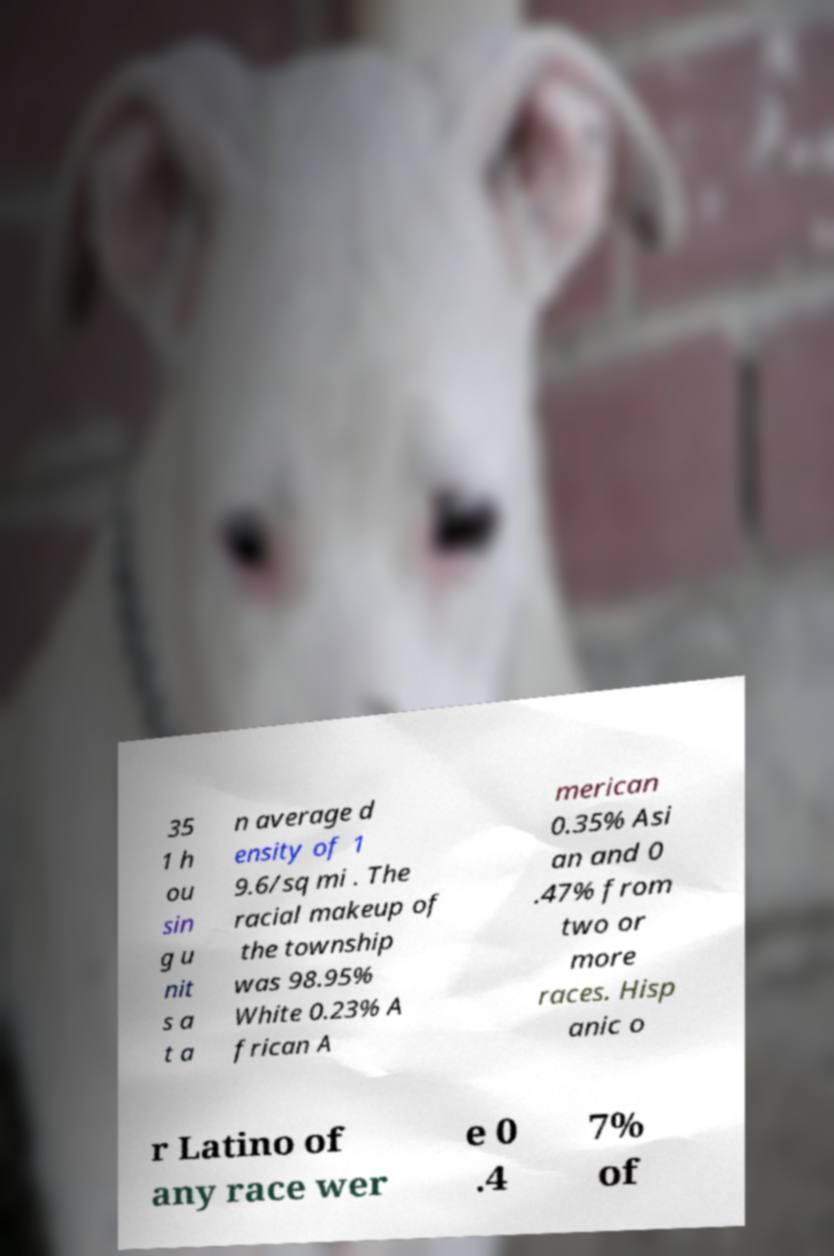Please identify and transcribe the text found in this image. 35 1 h ou sin g u nit s a t a n average d ensity of 1 9.6/sq mi . The racial makeup of the township was 98.95% White 0.23% A frican A merican 0.35% Asi an and 0 .47% from two or more races. Hisp anic o r Latino of any race wer e 0 .4 7% of 